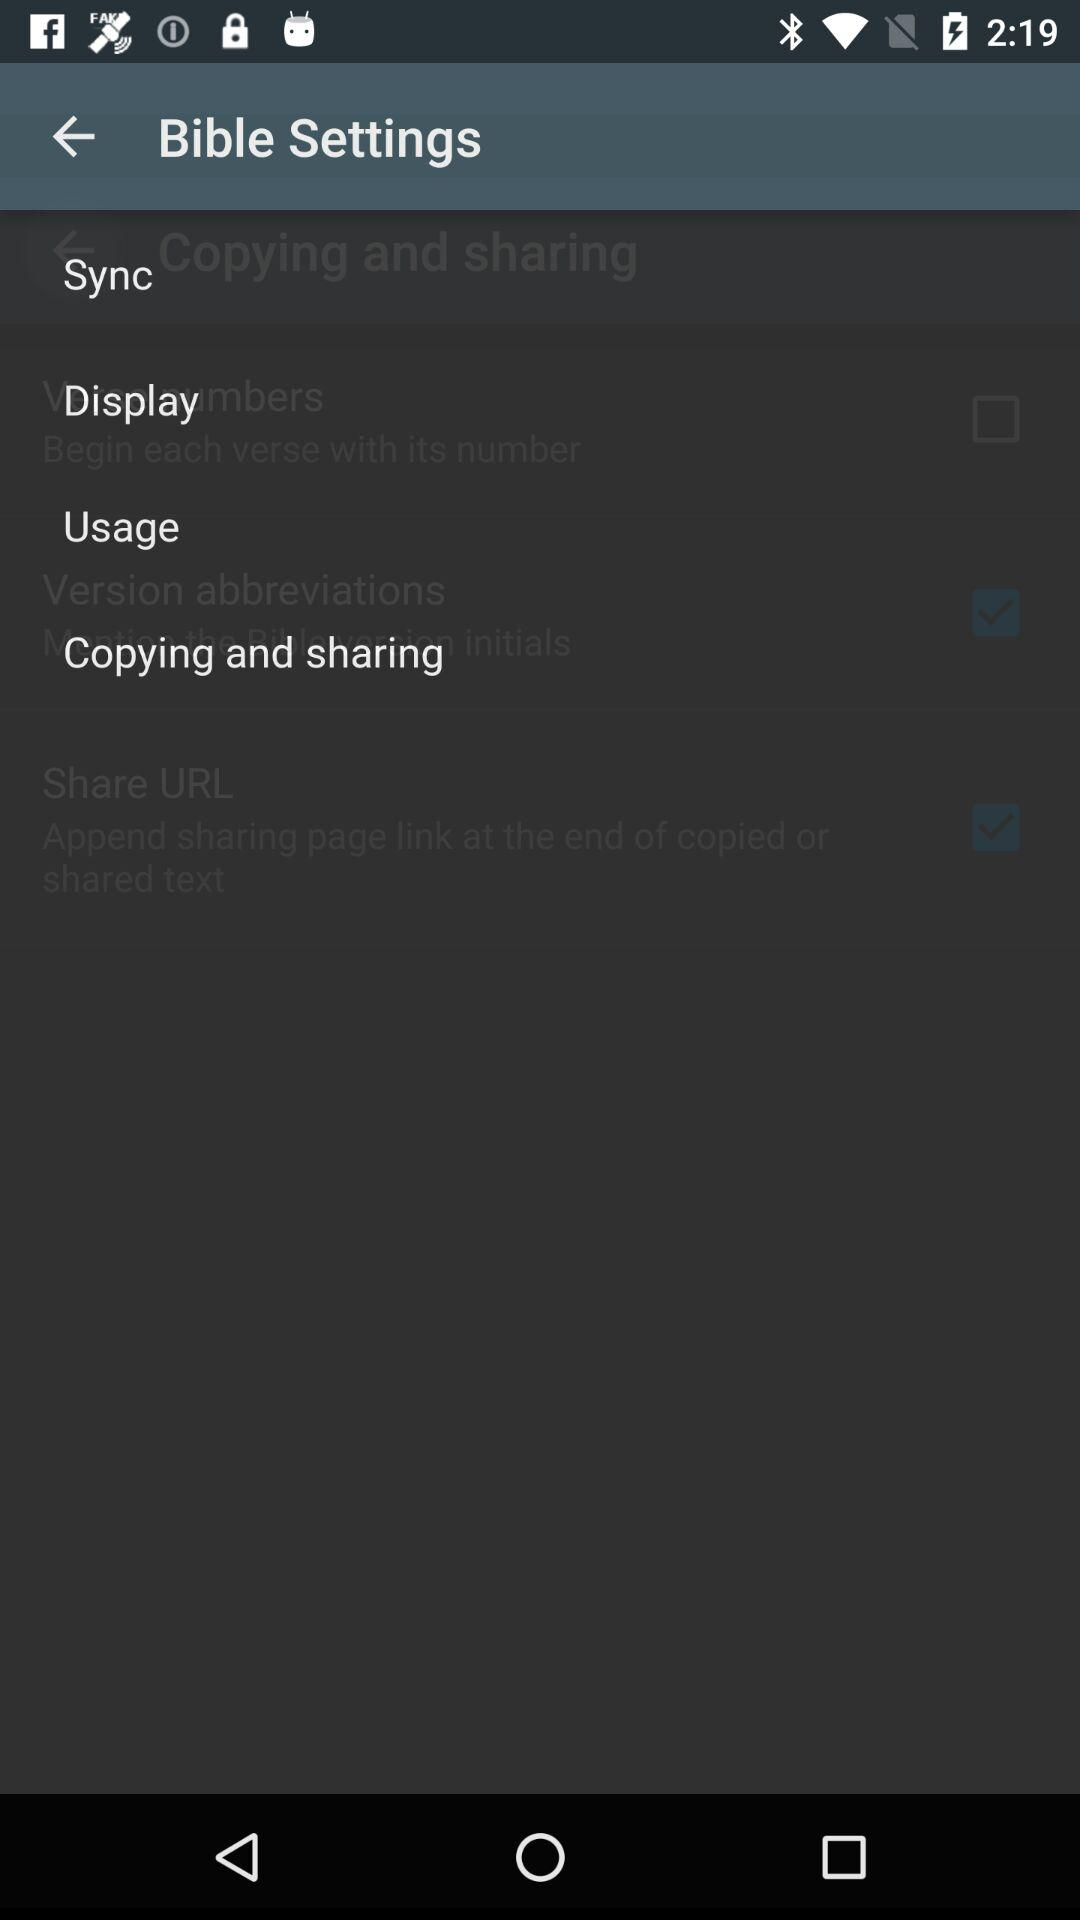How many items are in the Copying and sharing section?
Answer the question using a single word or phrase. 3 